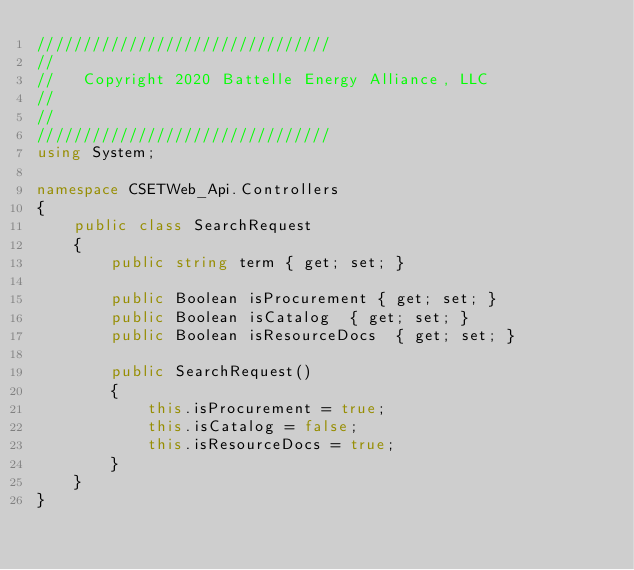<code> <loc_0><loc_0><loc_500><loc_500><_C#_>//////////////////////////////// 
// 
//   Copyright 2020 Battelle Energy Alliance, LLC  
// 
// 
//////////////////////////////// 
using System;

namespace CSETWeb_Api.Controllers
{
    public class SearchRequest
    {
        public string term { get; set; }

        public Boolean isProcurement { get; set; }
        public Boolean isCatalog  { get; set; }
        public Boolean isResourceDocs  { get; set; }

        public SearchRequest()
        {
            this.isProcurement = true;
            this.isCatalog = false;
            this.isResourceDocs = true;
        }
    }
}

</code> 